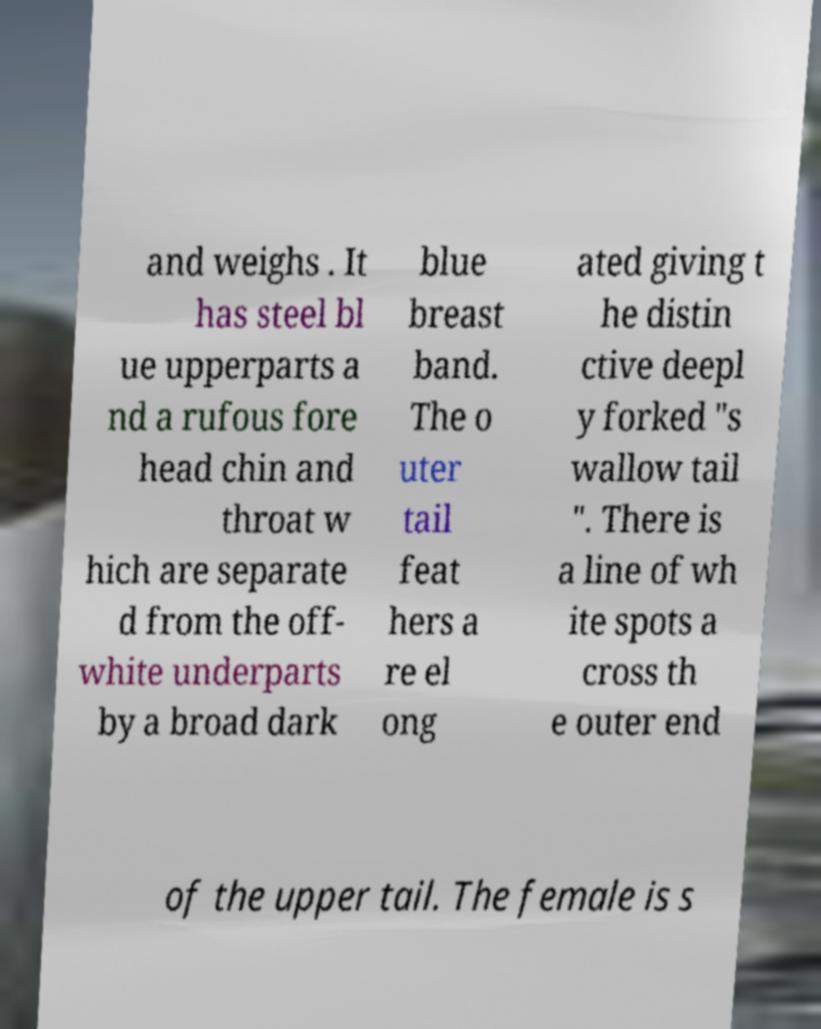There's text embedded in this image that I need extracted. Can you transcribe it verbatim? and weighs . It has steel bl ue upperparts a nd a rufous fore head chin and throat w hich are separate d from the off- white underparts by a broad dark blue breast band. The o uter tail feat hers a re el ong ated giving t he distin ctive deepl y forked "s wallow tail ". There is a line of wh ite spots a cross th e outer end of the upper tail. The female is s 